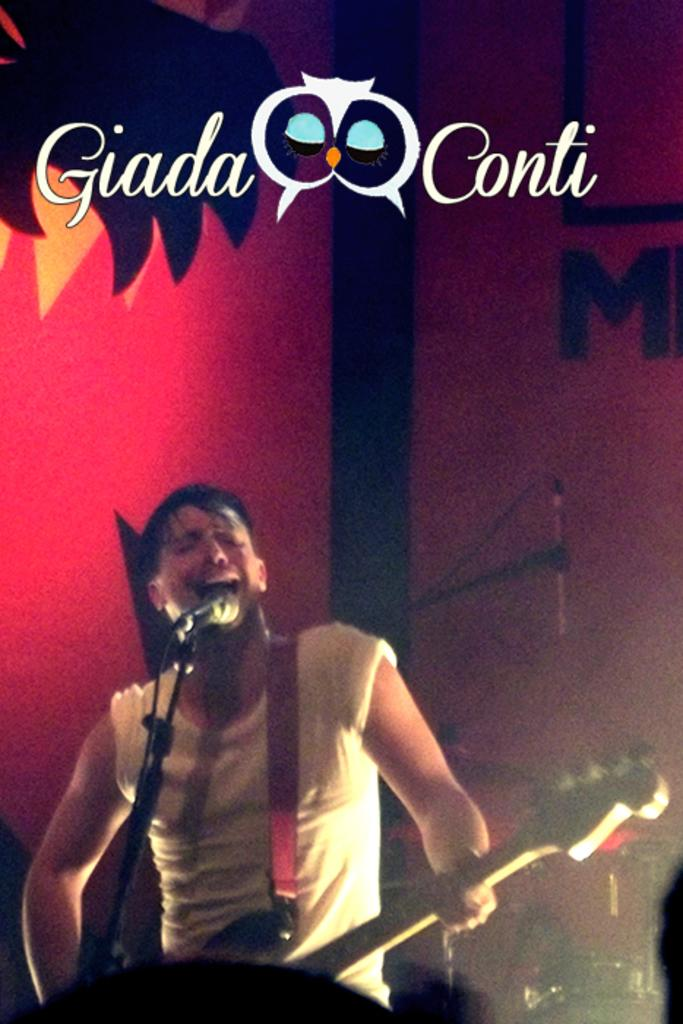What is the person on the stage doing? The person is playing a guitar. What can be seen behind the person on the stage? There is a wall with paintings behind the person. Is there any text visible in the image? Yes, there is some text at the top of the image. What type of oatmeal is being served to the audience in the image? There is no oatmeal or audience present in the image; it features a person playing a guitar on a stage with paintings on the wall and text at the top. 